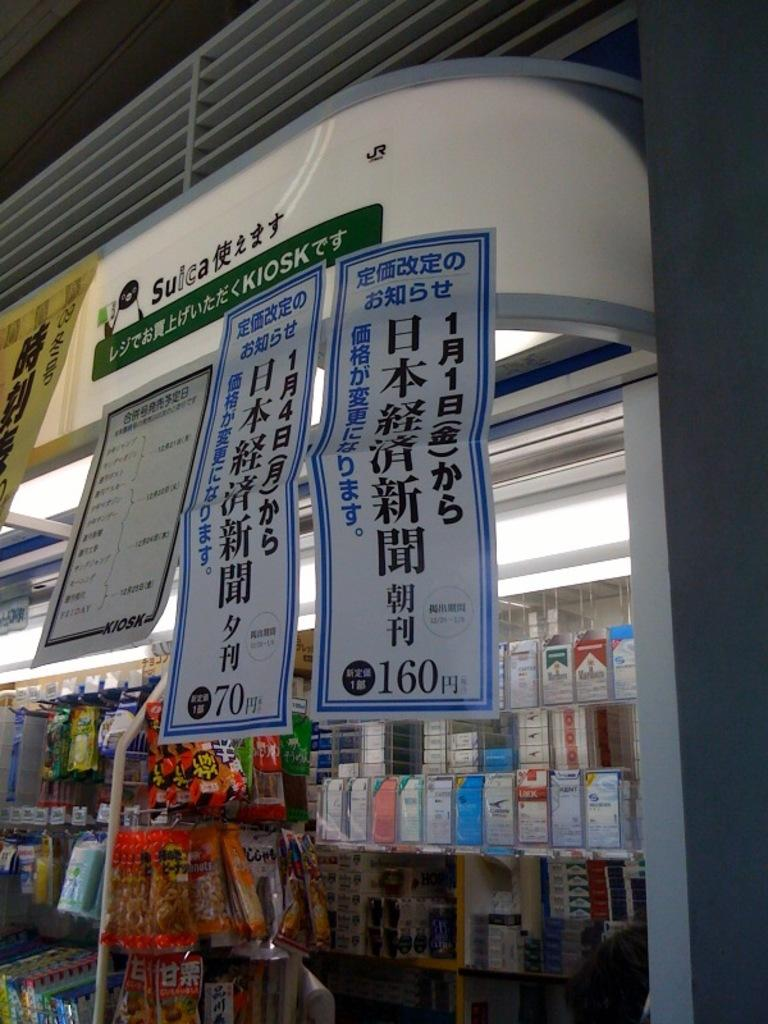<image>
Relay a brief, clear account of the picture shown. Retail store in China with Chinese posters on the window. 